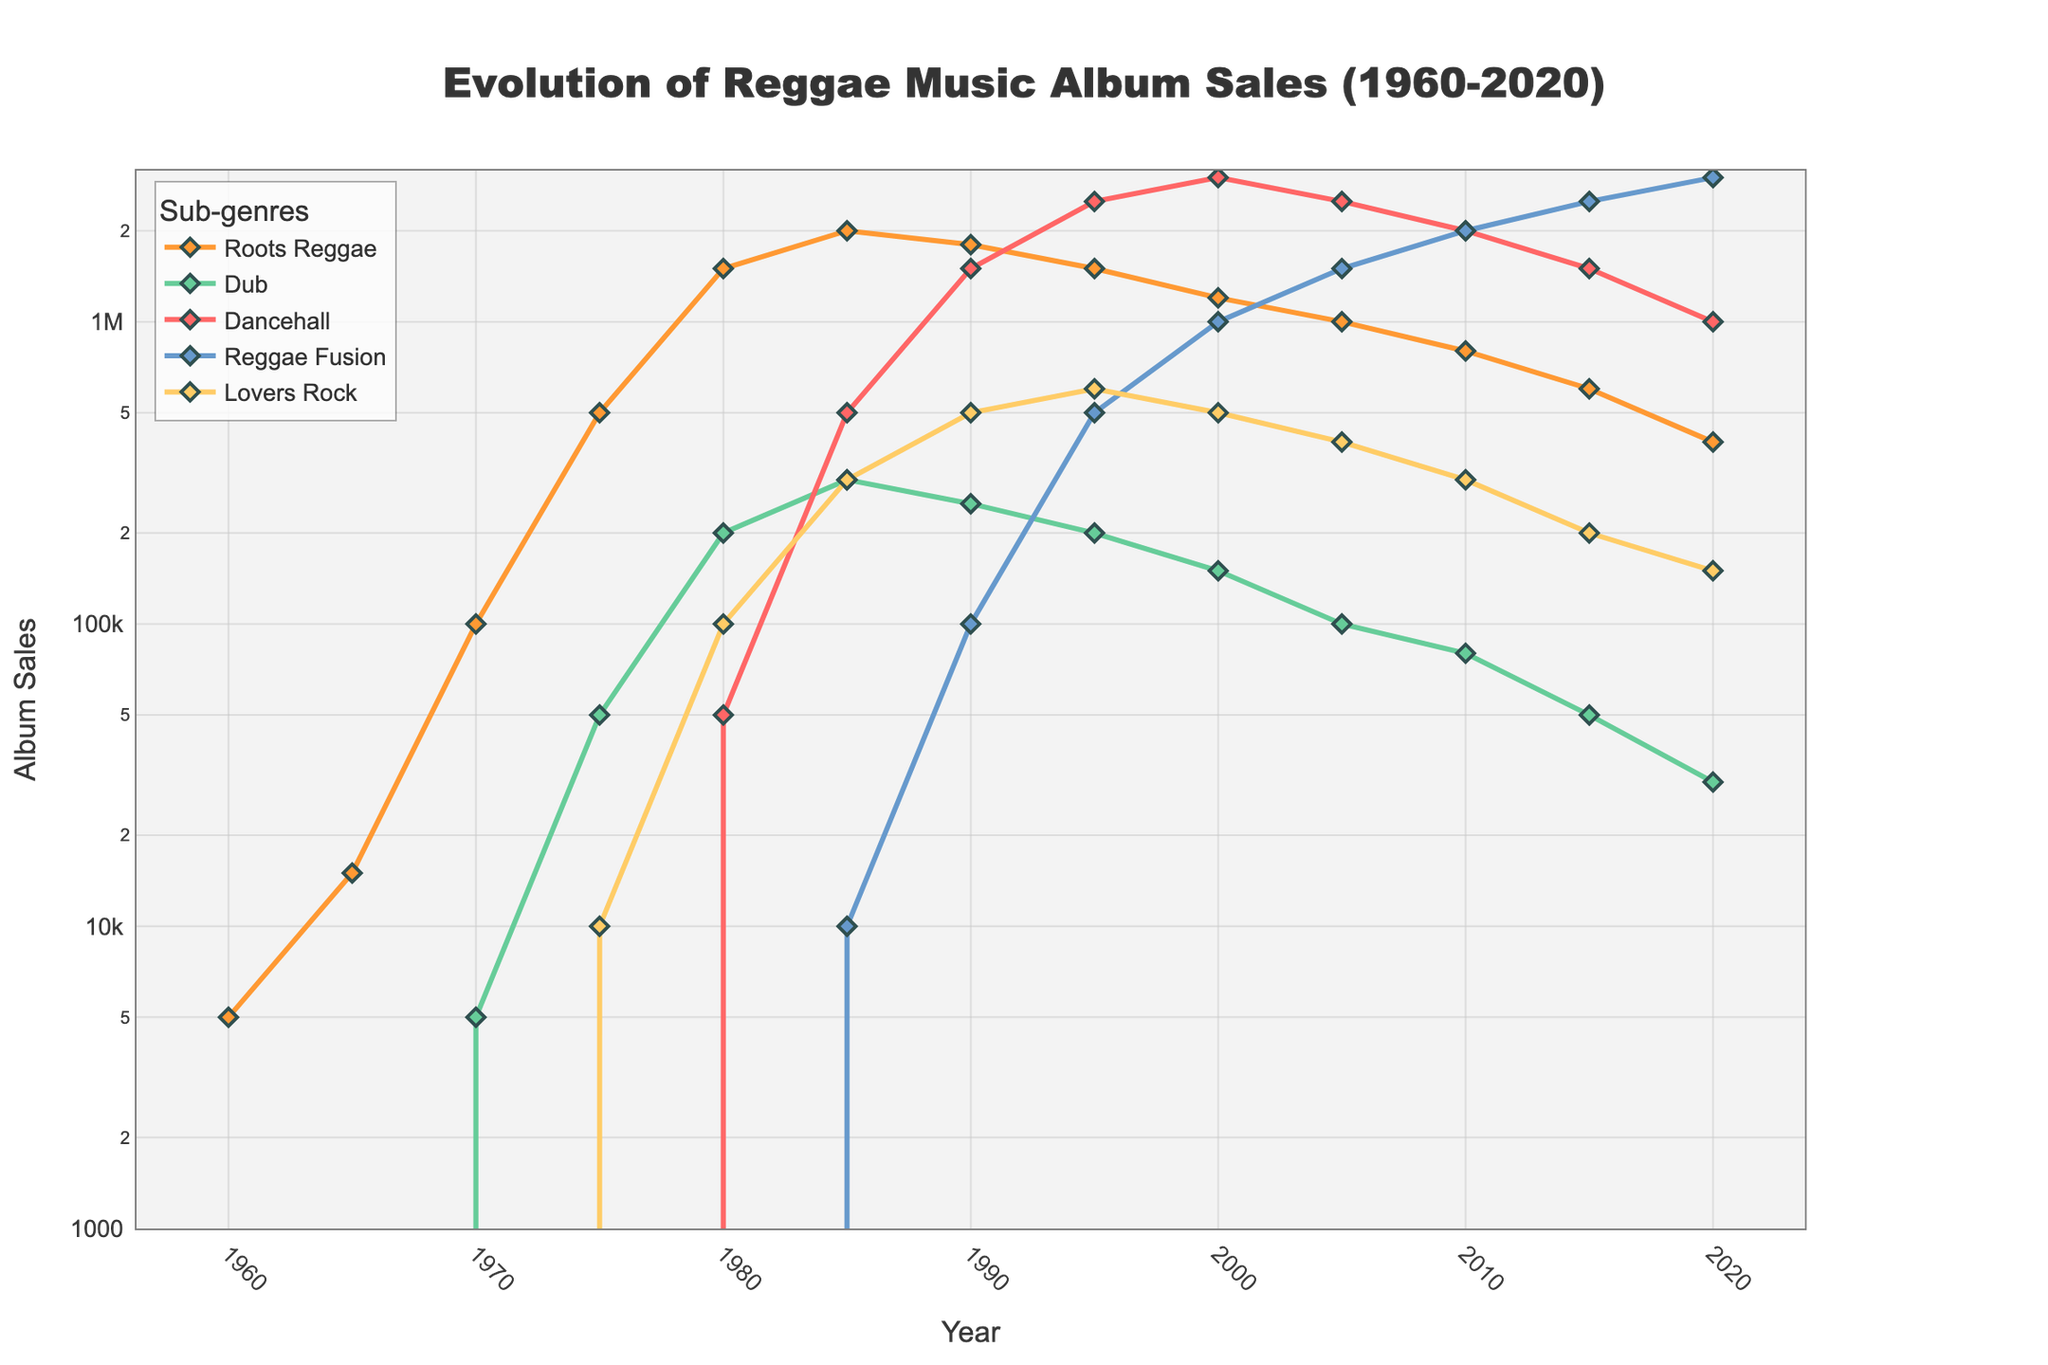what was the peak album sales for Roots Reggae? Find the highest point on the Roots Reggae line. The peak is around 1985 with album sales reaching 2,000,000.
Answer: 2,000,000 during which decade did Dub music see its first significant rise in album sales? Look at the Dub line and notice that it first rises significantly between 1970 and 1980.
Answer: 1970s which sub-genre had the highest sales in 2010? Observe where the lines intersect in 2010. Reggae Fusion's line is the highest at that point with sales of approximately 2,000,000.
Answer: Reggae Fusion in which year did Dancehall album sales surpass Roots Reggae album sales? Compare the Dancehall and Roots Reggae lines year by year. In 1990, Dancehall (1,500,000) surpasses Roots Reggae (1,800,000).
Answer: 1990 how many genres had album sales of at least 500,000 in 1985? Look at the values for all genres in 1985: Roots Reggae (2,000,000), Dub (300,000), Dancehall (500,000), Reggae Fusion (10,000), and Lovers Rock (300,000). Only Roots Reggae and Dancehall surpass 500,000. Two genres meet this criterion.
Answer: 2 in which year did Roots Reggae and Reggae Fusion have equal album sales? Check for intersection points between the Roots Reggae and Reggae Fusion lines. They both have 600,000 album sales in 2015.
Answer: 2015 what is the difference in sales between Roots Reggae and Lovers Rock in 2000? In 2000, Roots Reggae has 1,200,000 and Lovers Rock has 500,000. The difference is 1,200,000 - 500,000 = 700,000.
Answer: 700,000 between 1980 and 2020, which sub-genre consistently shows a decline in album sales? Observe lines from 1980 to 2020. Roots Reggae declines steadily from 1,500,000 in 1980 to 400,000 in 2020.
Answer: Roots Reggae which sub-genre showed the most growth from 1990 to 2000? Look at increases in album sales between 1990 and 2000 for all genres. Reggae Fusion grew from 100,000 to 1,000,000, the largest growth of 900,000.
Answer: Reggae Fusion what is the overall trend for Lovers Rock from 1980 to 2020? Observe the Lovers Rock line from 1980 to 2020. It starts at 100,000 in 1980, peaks at 600,000 in 1995, and then decreases to 150,000 in 2020. The overall trend is a rise followed by a fall.
Answer: rise then fall 